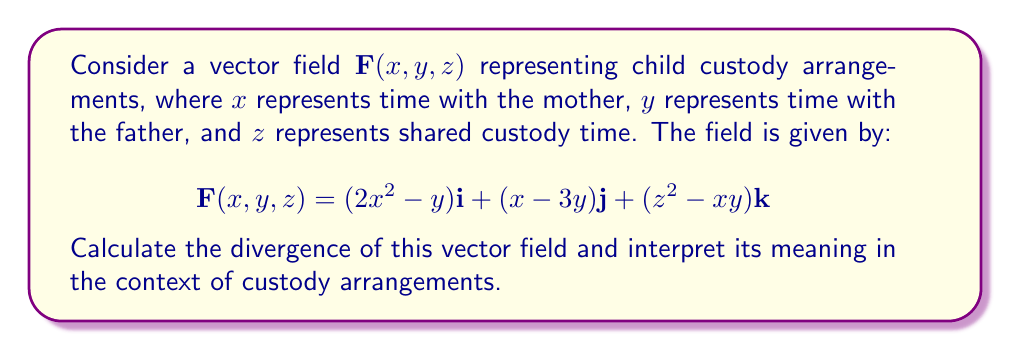Provide a solution to this math problem. To calculate the divergence of the vector field, we need to find the sum of the partial derivatives of each component with respect to its corresponding variable:

$$\text{div}\mathbf{F} = \nabla \cdot \mathbf{F} = \frac{\partial F_x}{\partial x} + \frac{\partial F_y}{\partial y} + \frac{\partial F_z}{\partial z}$$

Let's calculate each partial derivative:

1. $\frac{\partial F_x}{\partial x} = \frac{\partial}{\partial x}(2x^2 - y) = 4x$

2. $\frac{\partial F_y}{\partial y} = \frac{\partial}{\partial y}(x - 3y) = -3$

3. $\frac{\partial F_z}{\partial z} = \frac{\partial}{\partial z}(z^2 - xy) = 2z$

Now, we sum these partial derivatives:

$$\text{div}\mathbf{F} = 4x - 3 + 2z$$

Interpretation: The divergence represents the net outflow of the custody arrangement at any point $(x, y, z)$. A positive divergence indicates a tendency for custody time to increase, while a negative divergence suggests a decrease. The variable coefficients show that:

- As time with the mother $(x)$ increases, the divergence increases, suggesting a bias towards maternal custody.
- There's a constant negative term $(-3)$, which could represent a systemic bias against the father's custody time.
- Shared custody time $(z)$ positively contributes to the divergence, indicating that more shared time leads to a more balanced arrangement.
Answer: $$\text{div}\mathbf{F} = 4x - 3 + 2z$$ 